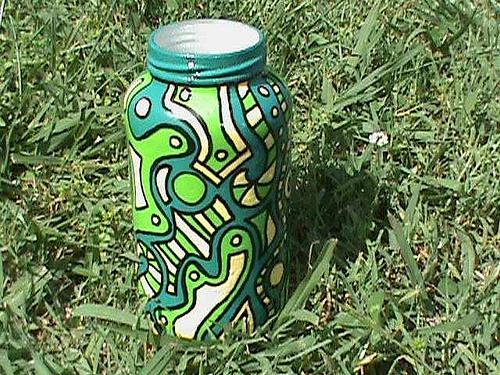Question: where is the shot taken?
Choices:
A. Garden.
B. Field.
C. Yard.
D. Park.
Answer with the letter. Answer: C Question: how many shades of green are on the jar?
Choices:
A. 3.
B. 2.
C. 1.
D. 0.
Answer with the letter. Answer: B 